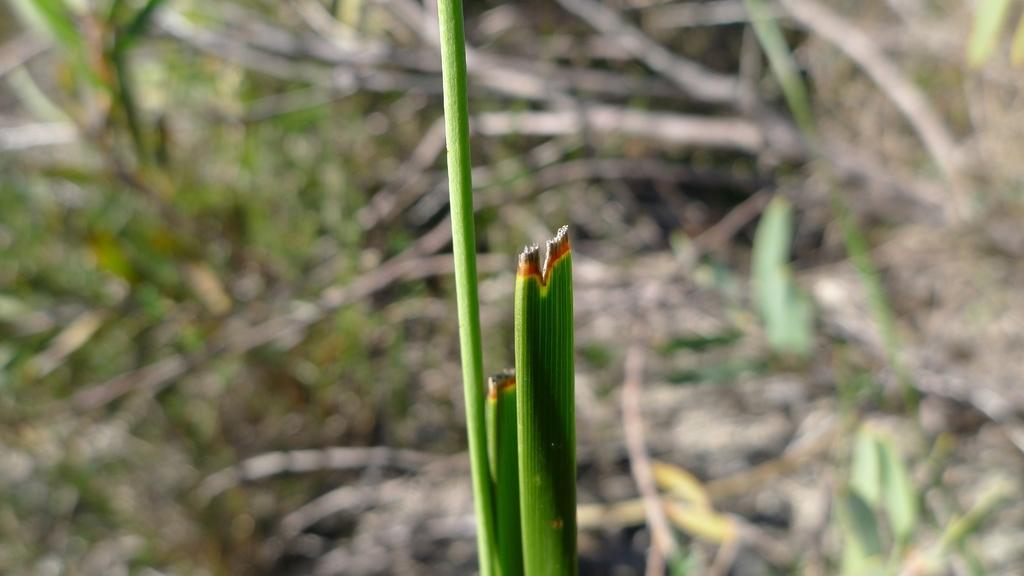Describe this image in one or two sentences. In the image there is a grass and the background of the grass is blue. 